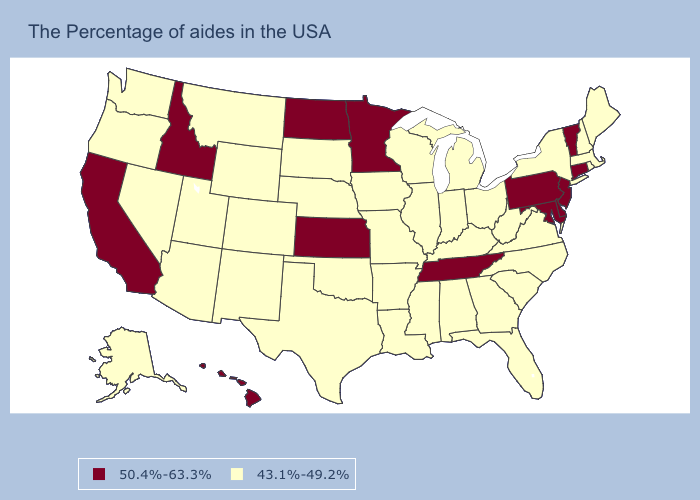What is the lowest value in states that border Nebraska?
Answer briefly. 43.1%-49.2%. Does Nebraska have a lower value than Maine?
Quick response, please. No. What is the value of Kansas?
Be succinct. 50.4%-63.3%. Name the states that have a value in the range 43.1%-49.2%?
Give a very brief answer. Maine, Massachusetts, Rhode Island, New Hampshire, New York, Virginia, North Carolina, South Carolina, West Virginia, Ohio, Florida, Georgia, Michigan, Kentucky, Indiana, Alabama, Wisconsin, Illinois, Mississippi, Louisiana, Missouri, Arkansas, Iowa, Nebraska, Oklahoma, Texas, South Dakota, Wyoming, Colorado, New Mexico, Utah, Montana, Arizona, Nevada, Washington, Oregon, Alaska. Which states hav the highest value in the West?
Give a very brief answer. Idaho, California, Hawaii. Name the states that have a value in the range 43.1%-49.2%?
Concise answer only. Maine, Massachusetts, Rhode Island, New Hampshire, New York, Virginia, North Carolina, South Carolina, West Virginia, Ohio, Florida, Georgia, Michigan, Kentucky, Indiana, Alabama, Wisconsin, Illinois, Mississippi, Louisiana, Missouri, Arkansas, Iowa, Nebraska, Oklahoma, Texas, South Dakota, Wyoming, Colorado, New Mexico, Utah, Montana, Arizona, Nevada, Washington, Oregon, Alaska. Which states have the lowest value in the USA?
Keep it brief. Maine, Massachusetts, Rhode Island, New Hampshire, New York, Virginia, North Carolina, South Carolina, West Virginia, Ohio, Florida, Georgia, Michigan, Kentucky, Indiana, Alabama, Wisconsin, Illinois, Mississippi, Louisiana, Missouri, Arkansas, Iowa, Nebraska, Oklahoma, Texas, South Dakota, Wyoming, Colorado, New Mexico, Utah, Montana, Arizona, Nevada, Washington, Oregon, Alaska. Name the states that have a value in the range 50.4%-63.3%?
Be succinct. Vermont, Connecticut, New Jersey, Delaware, Maryland, Pennsylvania, Tennessee, Minnesota, Kansas, North Dakota, Idaho, California, Hawaii. Does Tennessee have the highest value in the South?
Be succinct. Yes. What is the value of Louisiana?
Quick response, please. 43.1%-49.2%. What is the lowest value in states that border South Carolina?
Write a very short answer. 43.1%-49.2%. Does the map have missing data?
Quick response, please. No. What is the value of Kansas?
Keep it brief. 50.4%-63.3%. Does Rhode Island have the lowest value in the USA?
Give a very brief answer. Yes. Name the states that have a value in the range 43.1%-49.2%?
Quick response, please. Maine, Massachusetts, Rhode Island, New Hampshire, New York, Virginia, North Carolina, South Carolina, West Virginia, Ohio, Florida, Georgia, Michigan, Kentucky, Indiana, Alabama, Wisconsin, Illinois, Mississippi, Louisiana, Missouri, Arkansas, Iowa, Nebraska, Oklahoma, Texas, South Dakota, Wyoming, Colorado, New Mexico, Utah, Montana, Arizona, Nevada, Washington, Oregon, Alaska. 